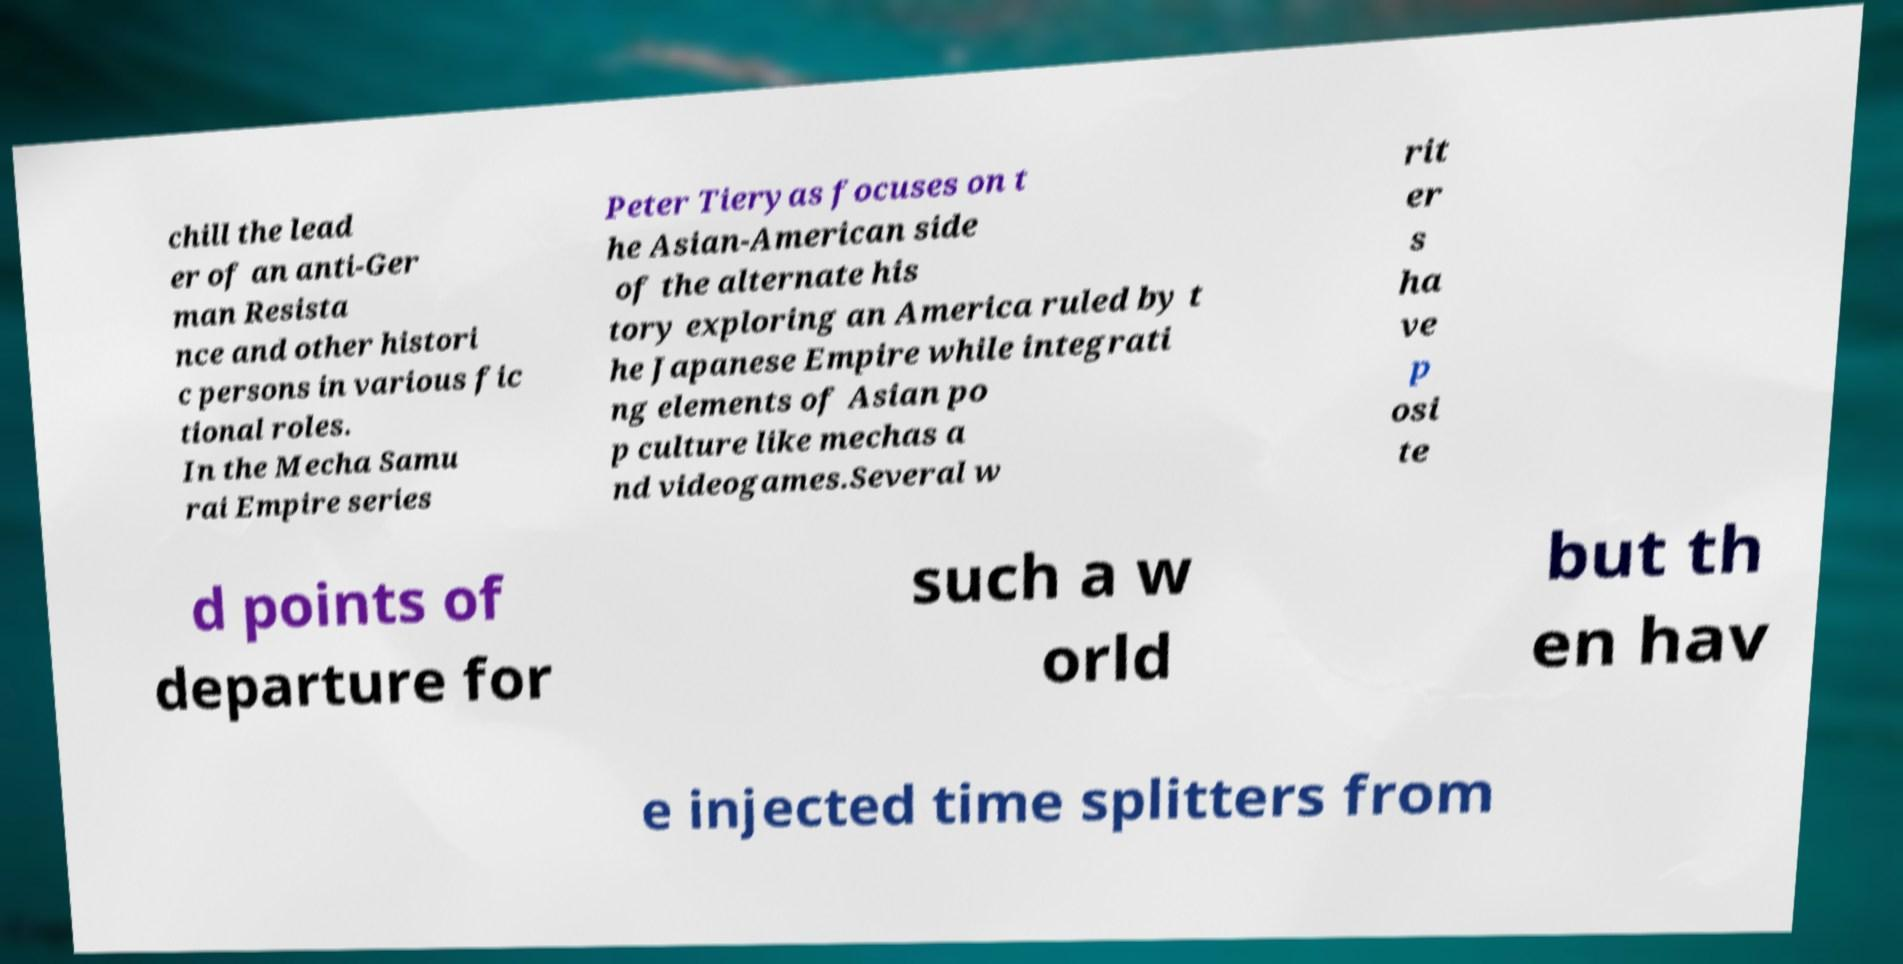What messages or text are displayed in this image? I need them in a readable, typed format. chill the lead er of an anti-Ger man Resista nce and other histori c persons in various fic tional roles. In the Mecha Samu rai Empire series Peter Tieryas focuses on t he Asian-American side of the alternate his tory exploring an America ruled by t he Japanese Empire while integrati ng elements of Asian po p culture like mechas a nd videogames.Several w rit er s ha ve p osi te d points of departure for such a w orld but th en hav e injected time splitters from 